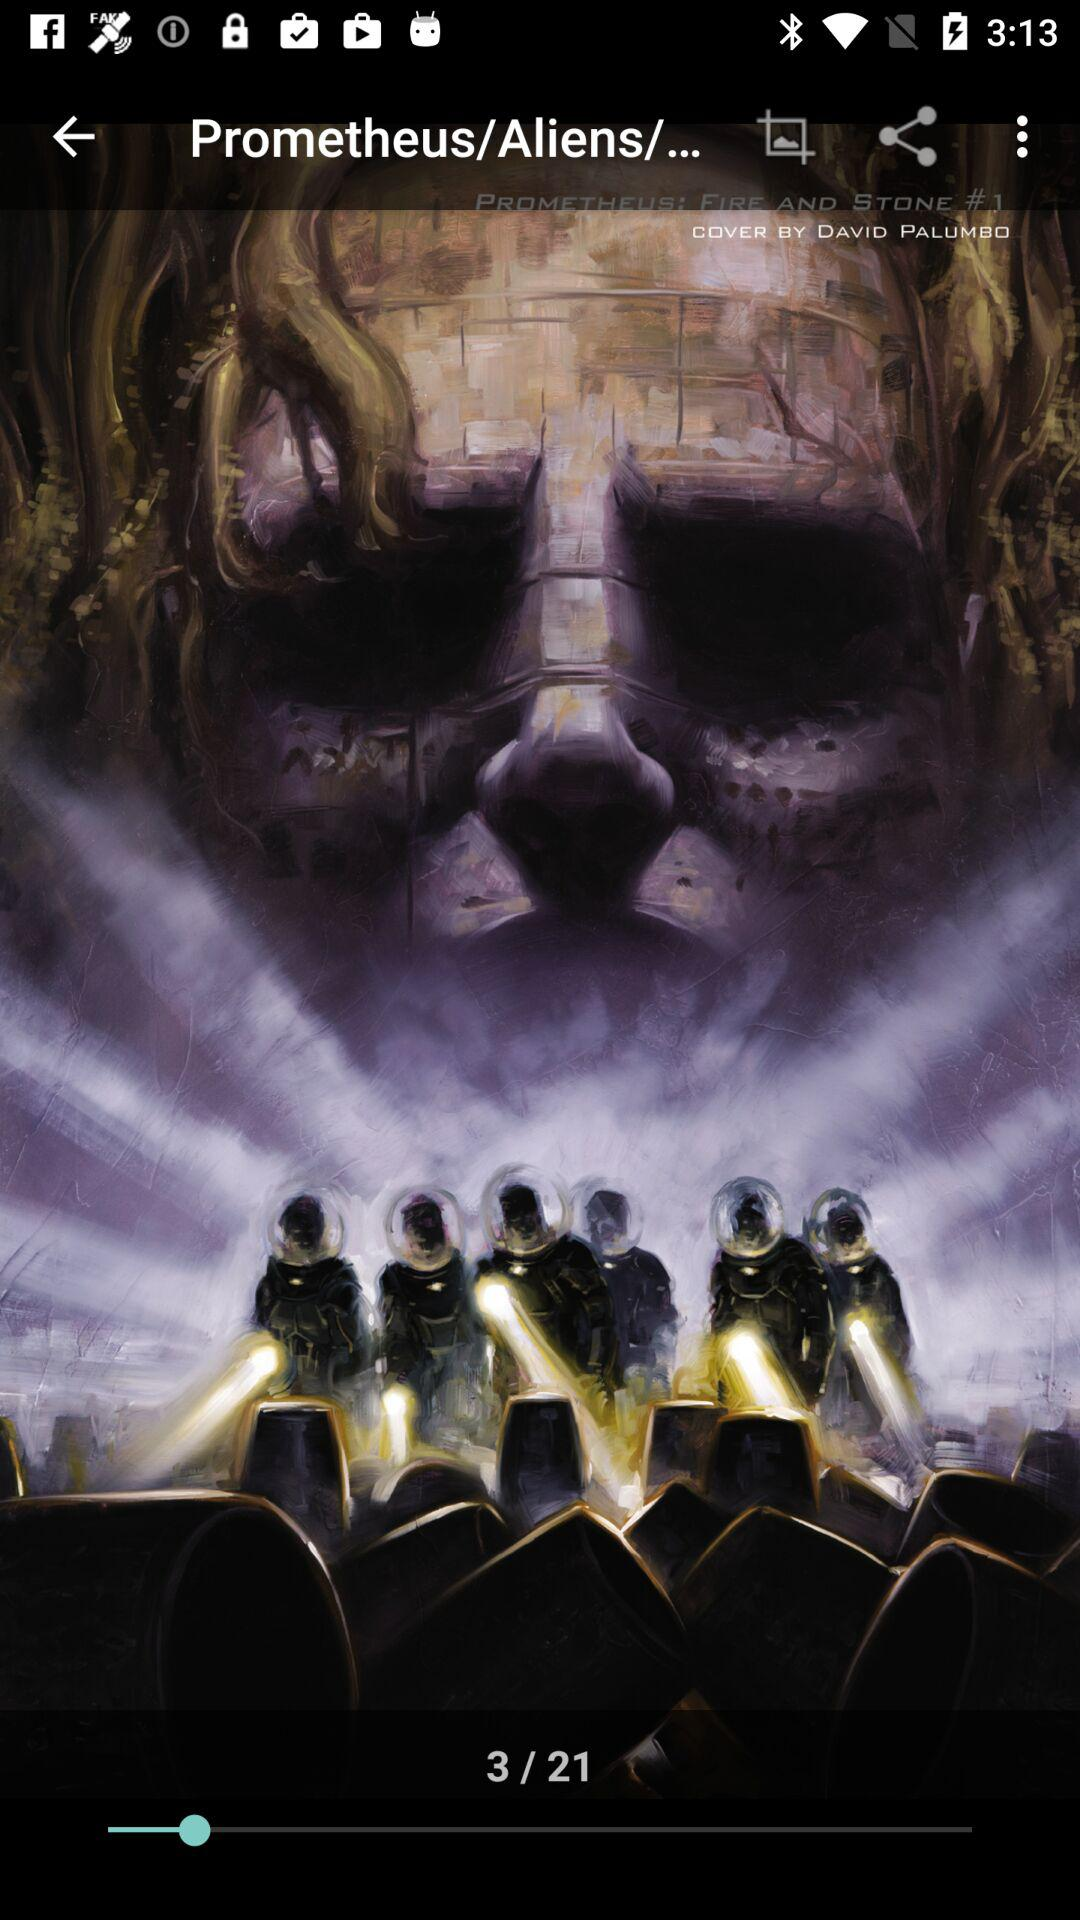How many images in total are there? There are 21 images. 